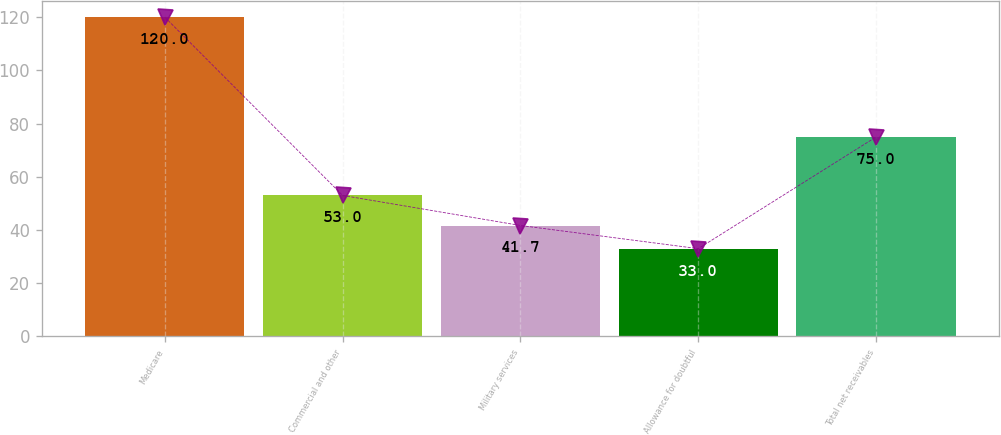<chart> <loc_0><loc_0><loc_500><loc_500><bar_chart><fcel>Medicare<fcel>Commercial and other<fcel>Military services<fcel>Allowance for doubtful<fcel>Total net receivables<nl><fcel>120<fcel>53<fcel>41.7<fcel>33<fcel>75<nl></chart> 